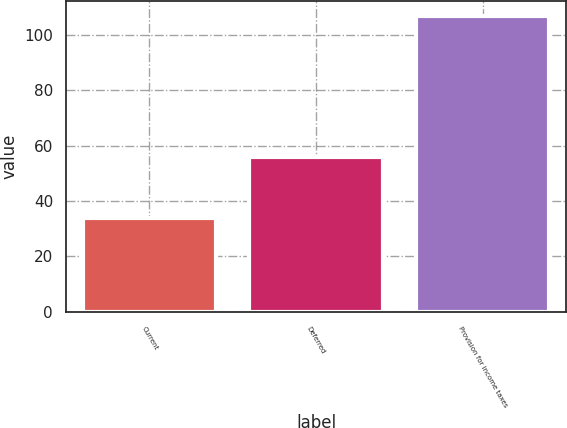Convert chart to OTSL. <chart><loc_0><loc_0><loc_500><loc_500><bar_chart><fcel>Current<fcel>Deferred<fcel>Provision for income taxes<nl><fcel>34<fcel>56<fcel>107<nl></chart> 